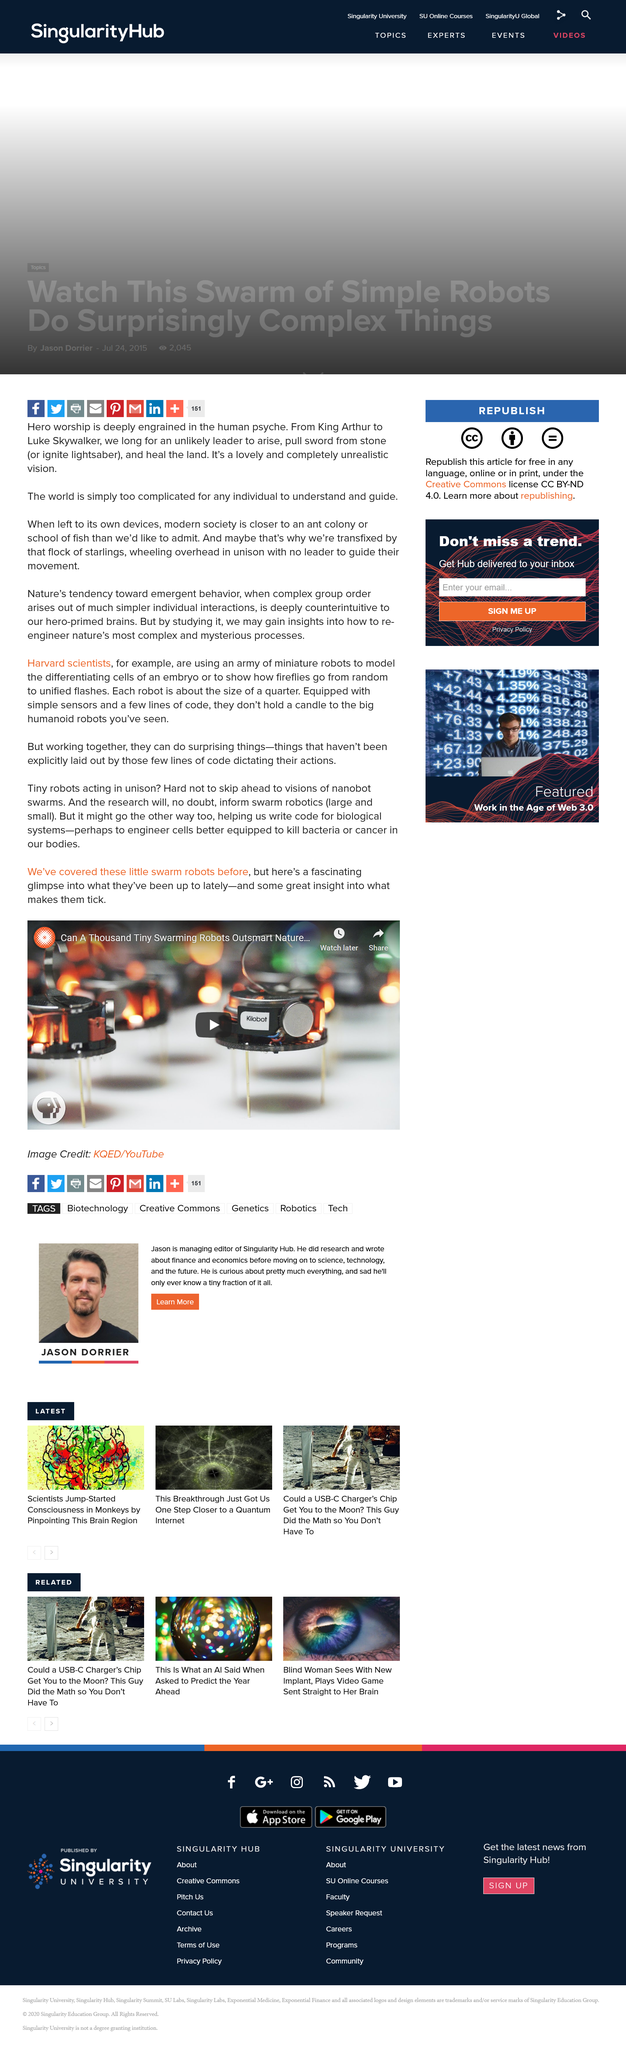Indicate a few pertinent items in this graphic. The Swarm robots described in the article are approximately the size of a quarter. Harvard scientists are developing an army of miniature robots. Swarm robots are impressive due to their ability to work together in unison, demonstrating a collective intelligence that surpasses that of individual robots. 